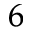<formula> <loc_0><loc_0><loc_500><loc_500>_ { 6 }</formula> 